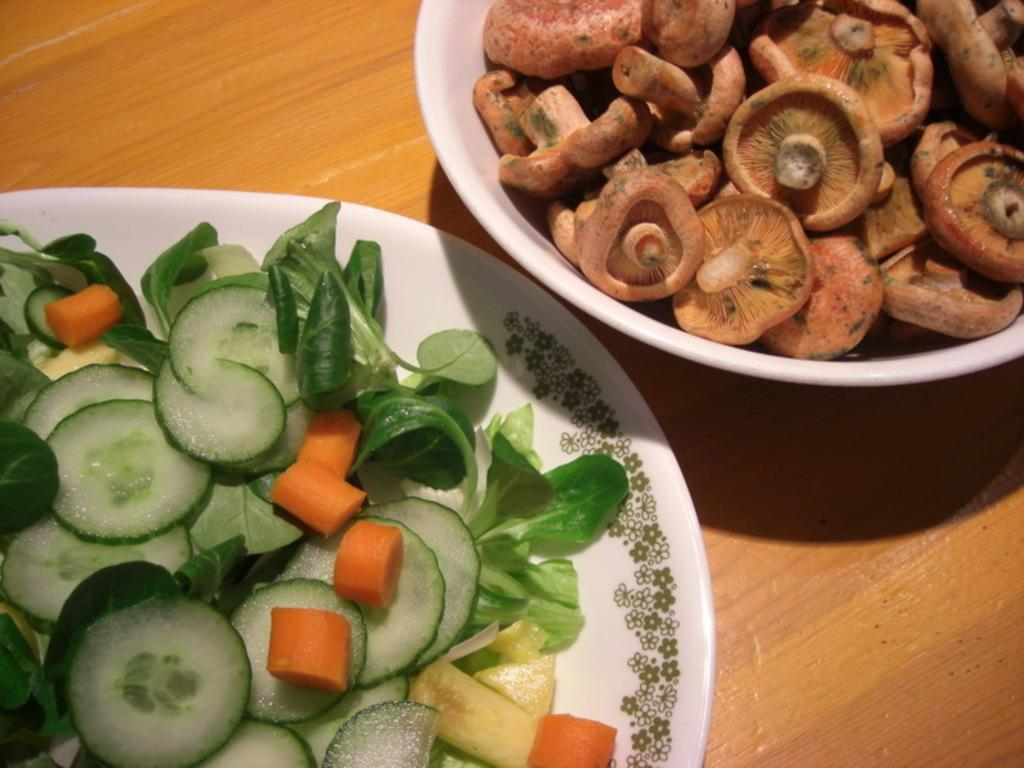What type of food is in the bowl in the image? There are mushrooms in a bowl in the image. What other type of food can be seen in the image? There are vegetables on a plate in the image. Where is the plate located in the image? The plate is on a wooden board in the image. How many laborers are visible in the image? There are no laborers present in the image. What is the grandmother doing in the image? There is no grandmother present in the image. 